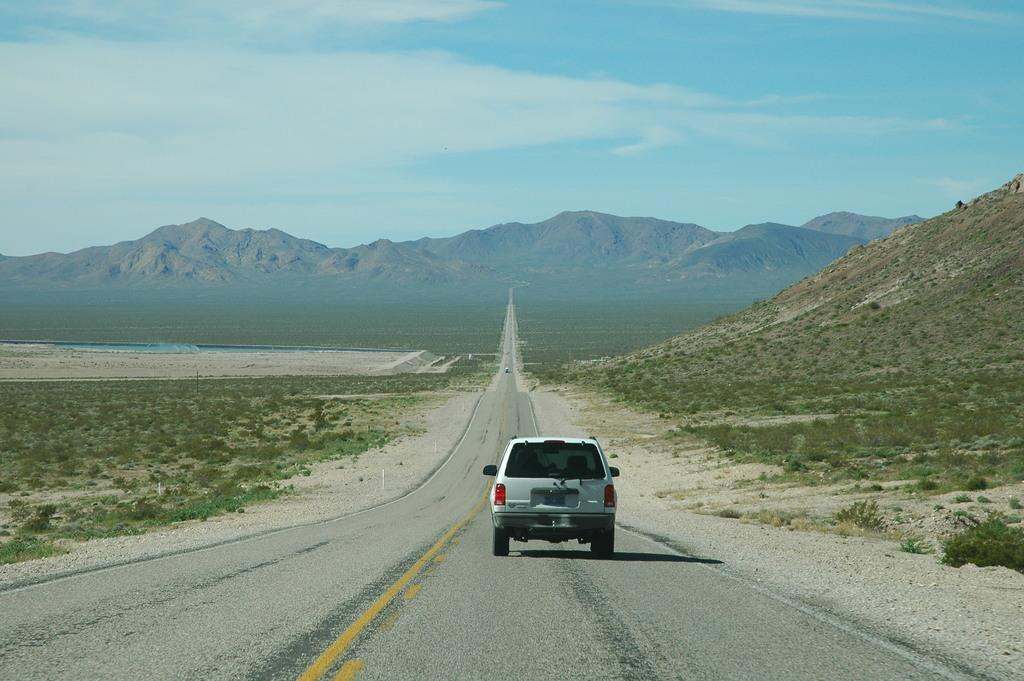What is the main subject of the image? There is a car on a road in the image. What type of landscape can be seen on the left side of the image? There is a grassland on the left side of the image. What type of landscape can be seen on the right side of the image? There is a mountain on the right side of the image. What is visible in the background of the image? There are mountains and the sky visible in the background of the image. What time of day is it in the image, and what color is the spark on the car's tongue? There is no indication of the time of day in the image, and there is no spark or tongue on the car. 